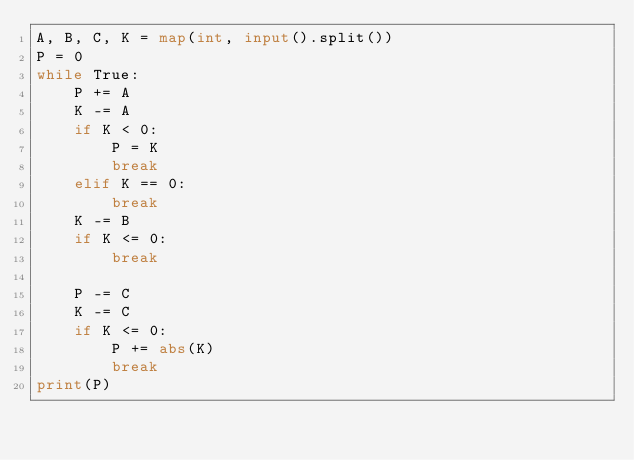<code> <loc_0><loc_0><loc_500><loc_500><_Python_>A, B, C, K = map(int, input().split())
P = 0
while True:
    P += A
    K -= A
    if K < 0:
        P = K
        break
    elif K == 0:
        break
    K -= B
    if K <= 0:
        break

    P -= C
    K -= C
    if K <= 0:
        P += abs(K)
        break
print(P)



</code> 